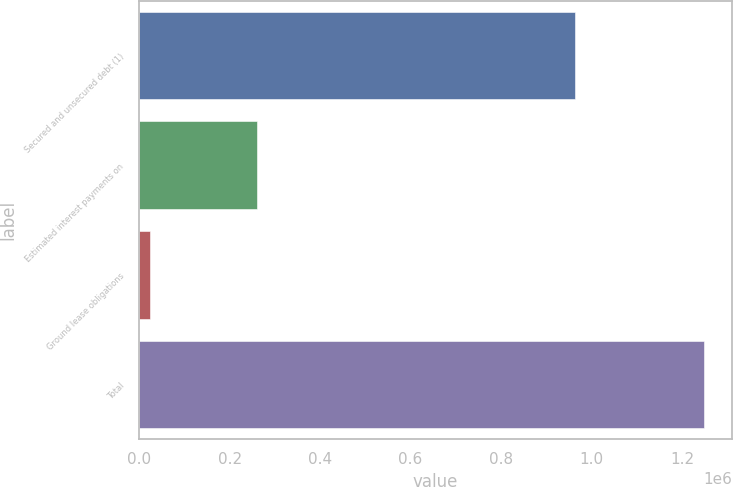Convert chart. <chart><loc_0><loc_0><loc_500><loc_500><bar_chart><fcel>Secured and unsecured debt (1)<fcel>Estimated interest payments on<fcel>Ground lease obligations<fcel>Total<nl><fcel>964151<fcel>259769<fcel>23376<fcel>1.24757e+06<nl></chart> 